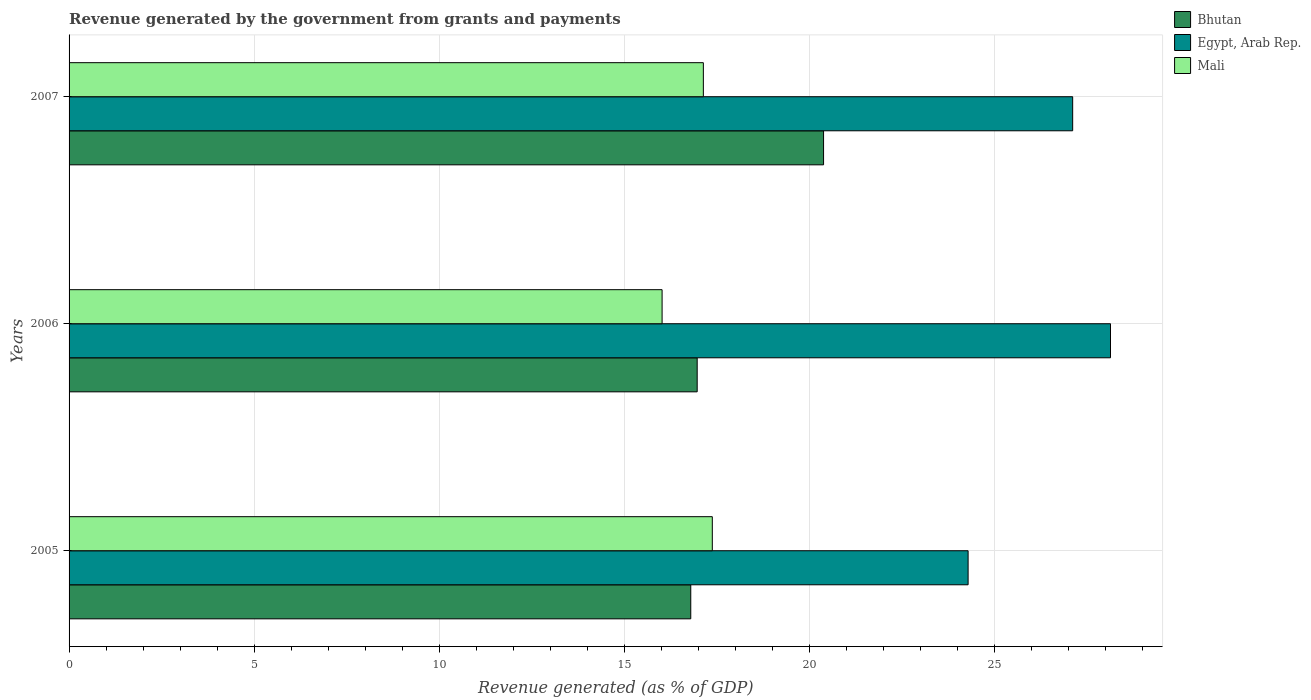How many different coloured bars are there?
Your answer should be very brief. 3. Are the number of bars on each tick of the Y-axis equal?
Ensure brevity in your answer.  Yes. How many bars are there on the 2nd tick from the top?
Provide a succinct answer. 3. How many bars are there on the 2nd tick from the bottom?
Offer a terse response. 3. What is the label of the 2nd group of bars from the top?
Offer a very short reply. 2006. What is the revenue generated by the government in Egypt, Arab Rep. in 2006?
Your answer should be very brief. 28.14. Across all years, what is the maximum revenue generated by the government in Mali?
Your response must be concise. 17.38. Across all years, what is the minimum revenue generated by the government in Mali?
Keep it short and to the point. 16.02. In which year was the revenue generated by the government in Mali maximum?
Offer a very short reply. 2005. What is the total revenue generated by the government in Bhutan in the graph?
Give a very brief answer. 54.16. What is the difference between the revenue generated by the government in Egypt, Arab Rep. in 2005 and that in 2007?
Offer a terse response. -2.83. What is the difference between the revenue generated by the government in Egypt, Arab Rep. in 2005 and the revenue generated by the government in Mali in 2007?
Your response must be concise. 7.15. What is the average revenue generated by the government in Egypt, Arab Rep. per year?
Provide a succinct answer. 26.52. In the year 2007, what is the difference between the revenue generated by the government in Mali and revenue generated by the government in Egypt, Arab Rep.?
Offer a very short reply. -9.98. What is the ratio of the revenue generated by the government in Egypt, Arab Rep. in 2006 to that in 2007?
Your answer should be very brief. 1.04. Is the difference between the revenue generated by the government in Mali in 2005 and 2006 greater than the difference between the revenue generated by the government in Egypt, Arab Rep. in 2005 and 2006?
Provide a succinct answer. Yes. What is the difference between the highest and the second highest revenue generated by the government in Mali?
Give a very brief answer. 0.24. What is the difference between the highest and the lowest revenue generated by the government in Mali?
Give a very brief answer. 1.36. In how many years, is the revenue generated by the government in Mali greater than the average revenue generated by the government in Mali taken over all years?
Your response must be concise. 2. What does the 2nd bar from the top in 2006 represents?
Your response must be concise. Egypt, Arab Rep. What does the 2nd bar from the bottom in 2005 represents?
Offer a very short reply. Egypt, Arab Rep. Is it the case that in every year, the sum of the revenue generated by the government in Bhutan and revenue generated by the government in Egypt, Arab Rep. is greater than the revenue generated by the government in Mali?
Offer a very short reply. Yes. Are all the bars in the graph horizontal?
Provide a succinct answer. Yes. How many years are there in the graph?
Give a very brief answer. 3. Does the graph contain grids?
Your answer should be very brief. Yes. How many legend labels are there?
Ensure brevity in your answer.  3. What is the title of the graph?
Offer a very short reply. Revenue generated by the government from grants and payments. Does "Papua New Guinea" appear as one of the legend labels in the graph?
Your answer should be compact. No. What is the label or title of the X-axis?
Give a very brief answer. Revenue generated (as % of GDP). What is the Revenue generated (as % of GDP) of Bhutan in 2005?
Provide a succinct answer. 16.8. What is the Revenue generated (as % of GDP) of Egypt, Arab Rep. in 2005?
Your answer should be compact. 24.29. What is the Revenue generated (as % of GDP) in Mali in 2005?
Offer a very short reply. 17.38. What is the Revenue generated (as % of GDP) in Bhutan in 2006?
Your answer should be very brief. 16.97. What is the Revenue generated (as % of GDP) of Egypt, Arab Rep. in 2006?
Keep it short and to the point. 28.14. What is the Revenue generated (as % of GDP) of Mali in 2006?
Make the answer very short. 16.02. What is the Revenue generated (as % of GDP) in Bhutan in 2007?
Your answer should be very brief. 20.39. What is the Revenue generated (as % of GDP) in Egypt, Arab Rep. in 2007?
Your response must be concise. 27.12. What is the Revenue generated (as % of GDP) of Mali in 2007?
Keep it short and to the point. 17.14. Across all years, what is the maximum Revenue generated (as % of GDP) in Bhutan?
Provide a succinct answer. 20.39. Across all years, what is the maximum Revenue generated (as % of GDP) in Egypt, Arab Rep.?
Provide a short and direct response. 28.14. Across all years, what is the maximum Revenue generated (as % of GDP) of Mali?
Your answer should be very brief. 17.38. Across all years, what is the minimum Revenue generated (as % of GDP) of Bhutan?
Offer a very short reply. 16.8. Across all years, what is the minimum Revenue generated (as % of GDP) of Egypt, Arab Rep.?
Ensure brevity in your answer.  24.29. Across all years, what is the minimum Revenue generated (as % of GDP) in Mali?
Offer a terse response. 16.02. What is the total Revenue generated (as % of GDP) of Bhutan in the graph?
Your answer should be compact. 54.16. What is the total Revenue generated (as % of GDP) in Egypt, Arab Rep. in the graph?
Your answer should be compact. 79.55. What is the total Revenue generated (as % of GDP) in Mali in the graph?
Offer a terse response. 50.54. What is the difference between the Revenue generated (as % of GDP) of Bhutan in 2005 and that in 2006?
Provide a succinct answer. -0.17. What is the difference between the Revenue generated (as % of GDP) of Egypt, Arab Rep. in 2005 and that in 2006?
Your response must be concise. -3.85. What is the difference between the Revenue generated (as % of GDP) of Mali in 2005 and that in 2006?
Make the answer very short. 1.36. What is the difference between the Revenue generated (as % of GDP) in Bhutan in 2005 and that in 2007?
Provide a short and direct response. -3.59. What is the difference between the Revenue generated (as % of GDP) in Egypt, Arab Rep. in 2005 and that in 2007?
Make the answer very short. -2.83. What is the difference between the Revenue generated (as % of GDP) of Mali in 2005 and that in 2007?
Offer a terse response. 0.24. What is the difference between the Revenue generated (as % of GDP) of Bhutan in 2006 and that in 2007?
Keep it short and to the point. -3.41. What is the difference between the Revenue generated (as % of GDP) of Egypt, Arab Rep. in 2006 and that in 2007?
Make the answer very short. 1.02. What is the difference between the Revenue generated (as % of GDP) of Mali in 2006 and that in 2007?
Your answer should be very brief. -1.11. What is the difference between the Revenue generated (as % of GDP) in Bhutan in 2005 and the Revenue generated (as % of GDP) in Egypt, Arab Rep. in 2006?
Your answer should be very brief. -11.34. What is the difference between the Revenue generated (as % of GDP) of Bhutan in 2005 and the Revenue generated (as % of GDP) of Mali in 2006?
Keep it short and to the point. 0.77. What is the difference between the Revenue generated (as % of GDP) in Egypt, Arab Rep. in 2005 and the Revenue generated (as % of GDP) in Mali in 2006?
Make the answer very short. 8.27. What is the difference between the Revenue generated (as % of GDP) in Bhutan in 2005 and the Revenue generated (as % of GDP) in Egypt, Arab Rep. in 2007?
Give a very brief answer. -10.32. What is the difference between the Revenue generated (as % of GDP) of Bhutan in 2005 and the Revenue generated (as % of GDP) of Mali in 2007?
Your response must be concise. -0.34. What is the difference between the Revenue generated (as % of GDP) of Egypt, Arab Rep. in 2005 and the Revenue generated (as % of GDP) of Mali in 2007?
Your answer should be very brief. 7.15. What is the difference between the Revenue generated (as % of GDP) in Bhutan in 2006 and the Revenue generated (as % of GDP) in Egypt, Arab Rep. in 2007?
Offer a very short reply. -10.15. What is the difference between the Revenue generated (as % of GDP) of Bhutan in 2006 and the Revenue generated (as % of GDP) of Mali in 2007?
Keep it short and to the point. -0.17. What is the difference between the Revenue generated (as % of GDP) of Egypt, Arab Rep. in 2006 and the Revenue generated (as % of GDP) of Mali in 2007?
Provide a succinct answer. 11. What is the average Revenue generated (as % of GDP) of Bhutan per year?
Offer a terse response. 18.05. What is the average Revenue generated (as % of GDP) of Egypt, Arab Rep. per year?
Offer a terse response. 26.52. What is the average Revenue generated (as % of GDP) in Mali per year?
Give a very brief answer. 16.85. In the year 2005, what is the difference between the Revenue generated (as % of GDP) of Bhutan and Revenue generated (as % of GDP) of Egypt, Arab Rep.?
Provide a short and direct response. -7.49. In the year 2005, what is the difference between the Revenue generated (as % of GDP) in Bhutan and Revenue generated (as % of GDP) in Mali?
Your response must be concise. -0.58. In the year 2005, what is the difference between the Revenue generated (as % of GDP) of Egypt, Arab Rep. and Revenue generated (as % of GDP) of Mali?
Offer a very short reply. 6.91. In the year 2006, what is the difference between the Revenue generated (as % of GDP) in Bhutan and Revenue generated (as % of GDP) in Egypt, Arab Rep.?
Give a very brief answer. -11.17. In the year 2006, what is the difference between the Revenue generated (as % of GDP) of Bhutan and Revenue generated (as % of GDP) of Mali?
Make the answer very short. 0.95. In the year 2006, what is the difference between the Revenue generated (as % of GDP) in Egypt, Arab Rep. and Revenue generated (as % of GDP) in Mali?
Ensure brevity in your answer.  12.12. In the year 2007, what is the difference between the Revenue generated (as % of GDP) of Bhutan and Revenue generated (as % of GDP) of Egypt, Arab Rep.?
Ensure brevity in your answer.  -6.73. In the year 2007, what is the difference between the Revenue generated (as % of GDP) of Bhutan and Revenue generated (as % of GDP) of Mali?
Your answer should be very brief. 3.25. In the year 2007, what is the difference between the Revenue generated (as % of GDP) in Egypt, Arab Rep. and Revenue generated (as % of GDP) in Mali?
Give a very brief answer. 9.98. What is the ratio of the Revenue generated (as % of GDP) of Bhutan in 2005 to that in 2006?
Provide a short and direct response. 0.99. What is the ratio of the Revenue generated (as % of GDP) of Egypt, Arab Rep. in 2005 to that in 2006?
Make the answer very short. 0.86. What is the ratio of the Revenue generated (as % of GDP) in Mali in 2005 to that in 2006?
Provide a succinct answer. 1.08. What is the ratio of the Revenue generated (as % of GDP) of Bhutan in 2005 to that in 2007?
Make the answer very short. 0.82. What is the ratio of the Revenue generated (as % of GDP) of Egypt, Arab Rep. in 2005 to that in 2007?
Your answer should be very brief. 0.9. What is the ratio of the Revenue generated (as % of GDP) of Mali in 2005 to that in 2007?
Your answer should be compact. 1.01. What is the ratio of the Revenue generated (as % of GDP) of Bhutan in 2006 to that in 2007?
Your response must be concise. 0.83. What is the ratio of the Revenue generated (as % of GDP) in Egypt, Arab Rep. in 2006 to that in 2007?
Provide a succinct answer. 1.04. What is the ratio of the Revenue generated (as % of GDP) in Mali in 2006 to that in 2007?
Your response must be concise. 0.94. What is the difference between the highest and the second highest Revenue generated (as % of GDP) of Bhutan?
Keep it short and to the point. 3.41. What is the difference between the highest and the second highest Revenue generated (as % of GDP) of Egypt, Arab Rep.?
Provide a succinct answer. 1.02. What is the difference between the highest and the second highest Revenue generated (as % of GDP) in Mali?
Offer a very short reply. 0.24. What is the difference between the highest and the lowest Revenue generated (as % of GDP) of Bhutan?
Provide a succinct answer. 3.59. What is the difference between the highest and the lowest Revenue generated (as % of GDP) in Egypt, Arab Rep.?
Your answer should be compact. 3.85. What is the difference between the highest and the lowest Revenue generated (as % of GDP) in Mali?
Give a very brief answer. 1.36. 